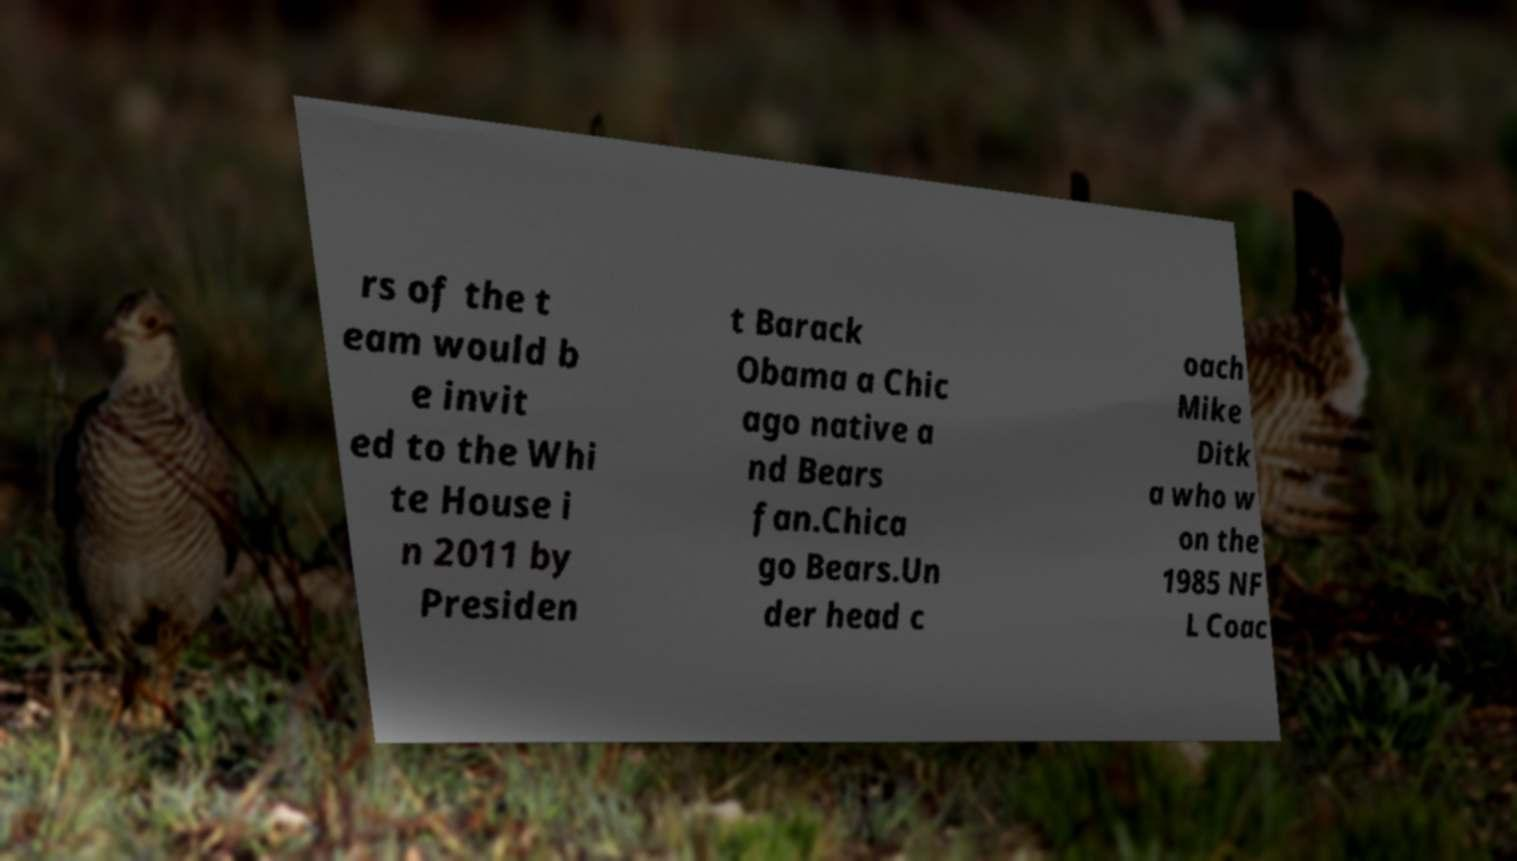For documentation purposes, I need the text within this image transcribed. Could you provide that? rs of the t eam would b e invit ed to the Whi te House i n 2011 by Presiden t Barack Obama a Chic ago native a nd Bears fan.Chica go Bears.Un der head c oach Mike Ditk a who w on the 1985 NF L Coac 